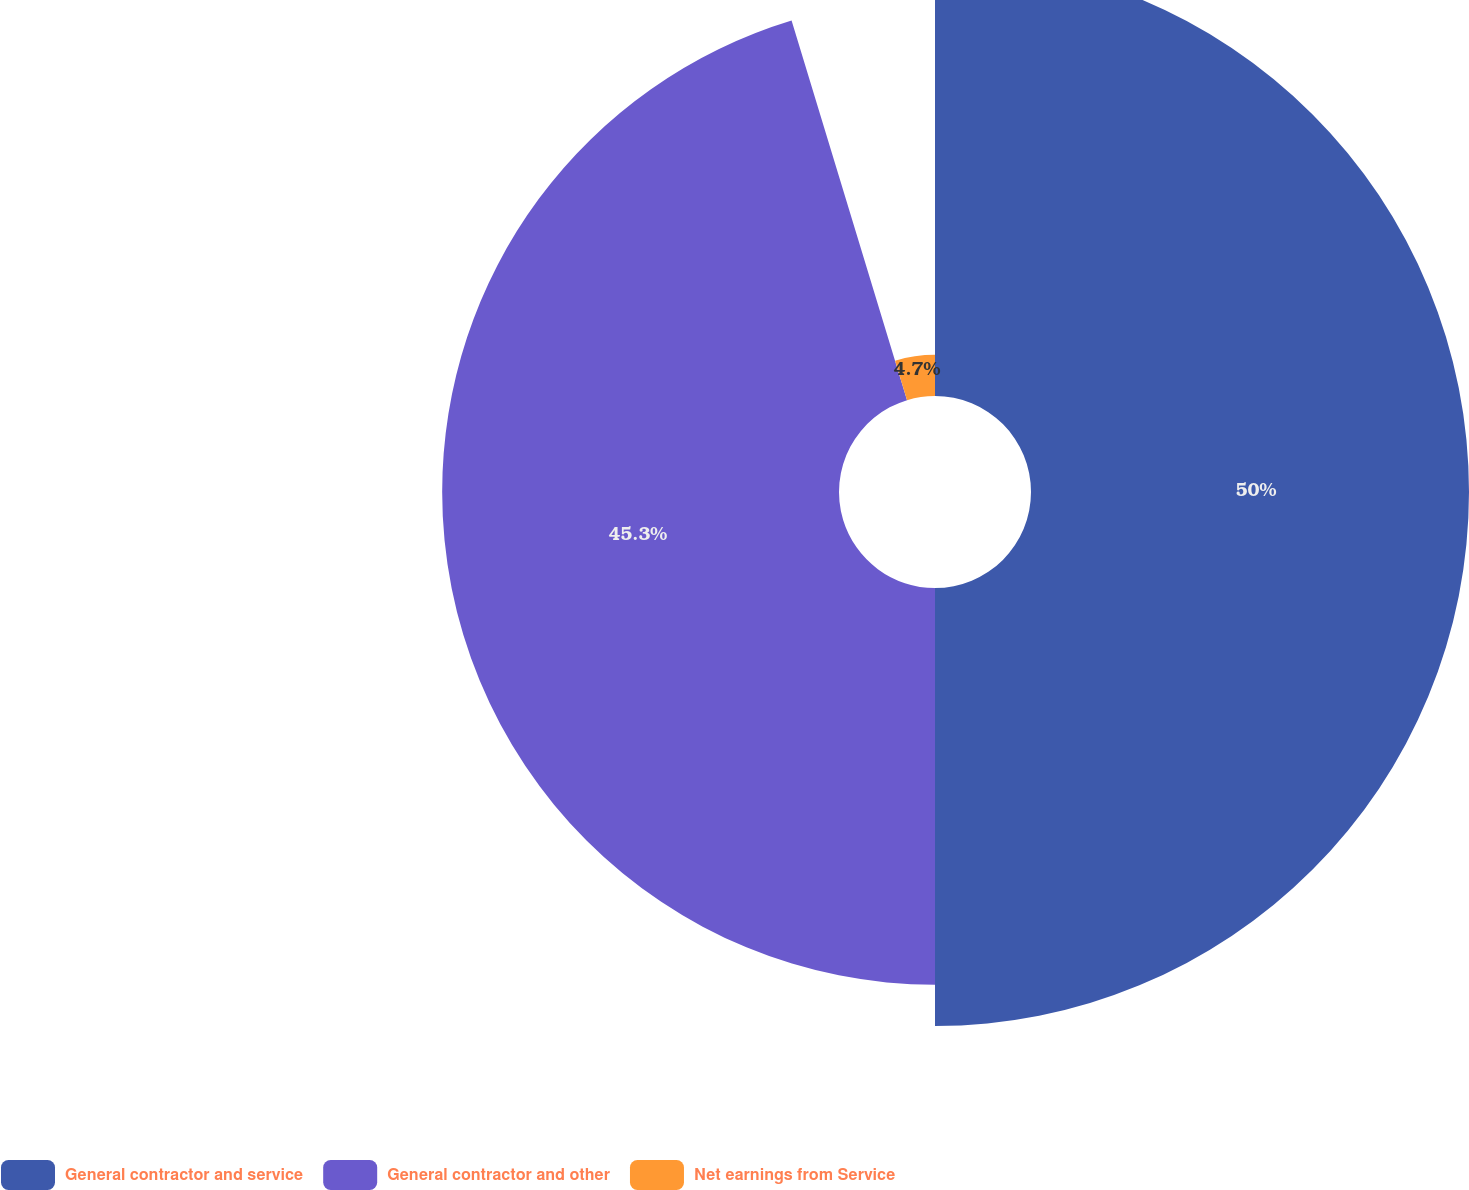Convert chart. <chart><loc_0><loc_0><loc_500><loc_500><pie_chart><fcel>General contractor and service<fcel>General contractor and other<fcel>Net earnings from Service<nl><fcel>50.0%<fcel>45.3%<fcel>4.7%<nl></chart> 